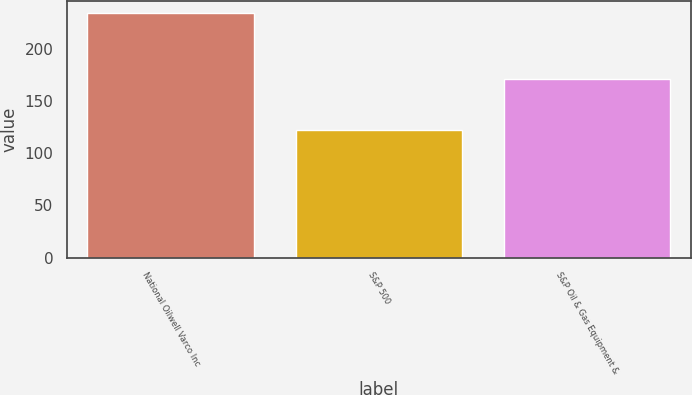<chart> <loc_0><loc_0><loc_500><loc_500><bar_chart><fcel>National Oilwell Varco Inc<fcel>S&P 500<fcel>S&P Oil & Gas Equipment &<nl><fcel>234.32<fcel>122.16<fcel>170.88<nl></chart> 